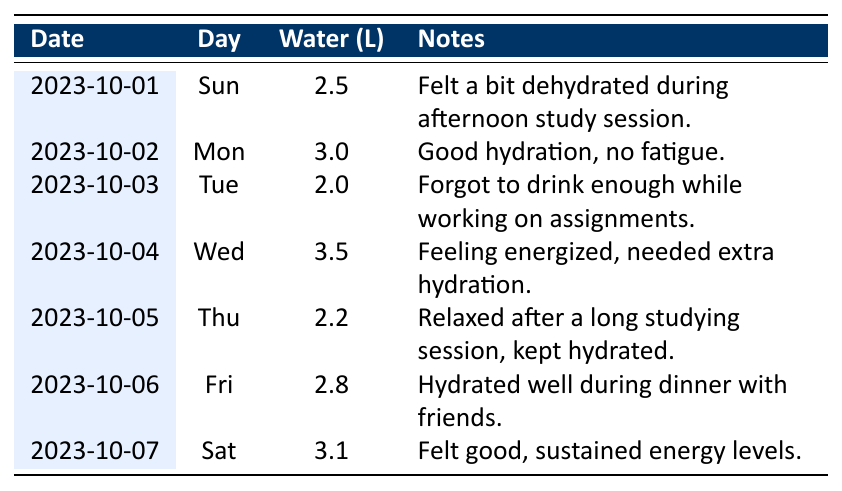What was the highest water intake recorded in the week? The table shows the daily water intake values for the week. Scanning through the values, the highest recorded water intake is 3.5 liters on Wednesday, October 4th.
Answer: 3.5 liters How many liters of water did you drink in total over the week? To find the total water intake, we sum all the daily water intake values: 2.5 + 3.0 + 2.0 + 3.5 + 2.2 + 2.8 + 3.1 = 19.1 liters.
Answer: 19.1 liters Did you stay well-hydrated on Monday according to the notes? The notes for Monday state "Good hydration, no fatigue," which indicates that hydration levels were adequate.
Answer: Yes Was there any day when you felt dehydrated while studying? On Sunday, the notes mention, "Felt a bit dehydrated during afternoon study session," showing that on that day, the feeling of dehydration was present.
Answer: Yes What is the average water intake for the week? The average water intake can be calculated by dividing the total water consumed (19.1 liters) by the number of days (7). So, average = 19.1/7 ≈ 2.73 liters.
Answer: 2.73 liters Which day did you consume the least amount of water, and what was it? By reviewing each day's water intake, Tuesday had the least amount at 2.0 liters.
Answer: Tuesday, 2.0 liters On which day did you report feeling energized, and how much water did you consume that day? The notes for Wednesday indicate "Feeling energized," and on that day, the water intake was 3.5 liters.
Answer: Wednesday, 3.5 liters Was there any day you consumed more than 3 liters of water? Reviewing the daily water intake, both Monday (3.0 liters) and Wednesday (3.5 liters) exceeded 3 liters, so the answer is yes.
Answer: Yes 